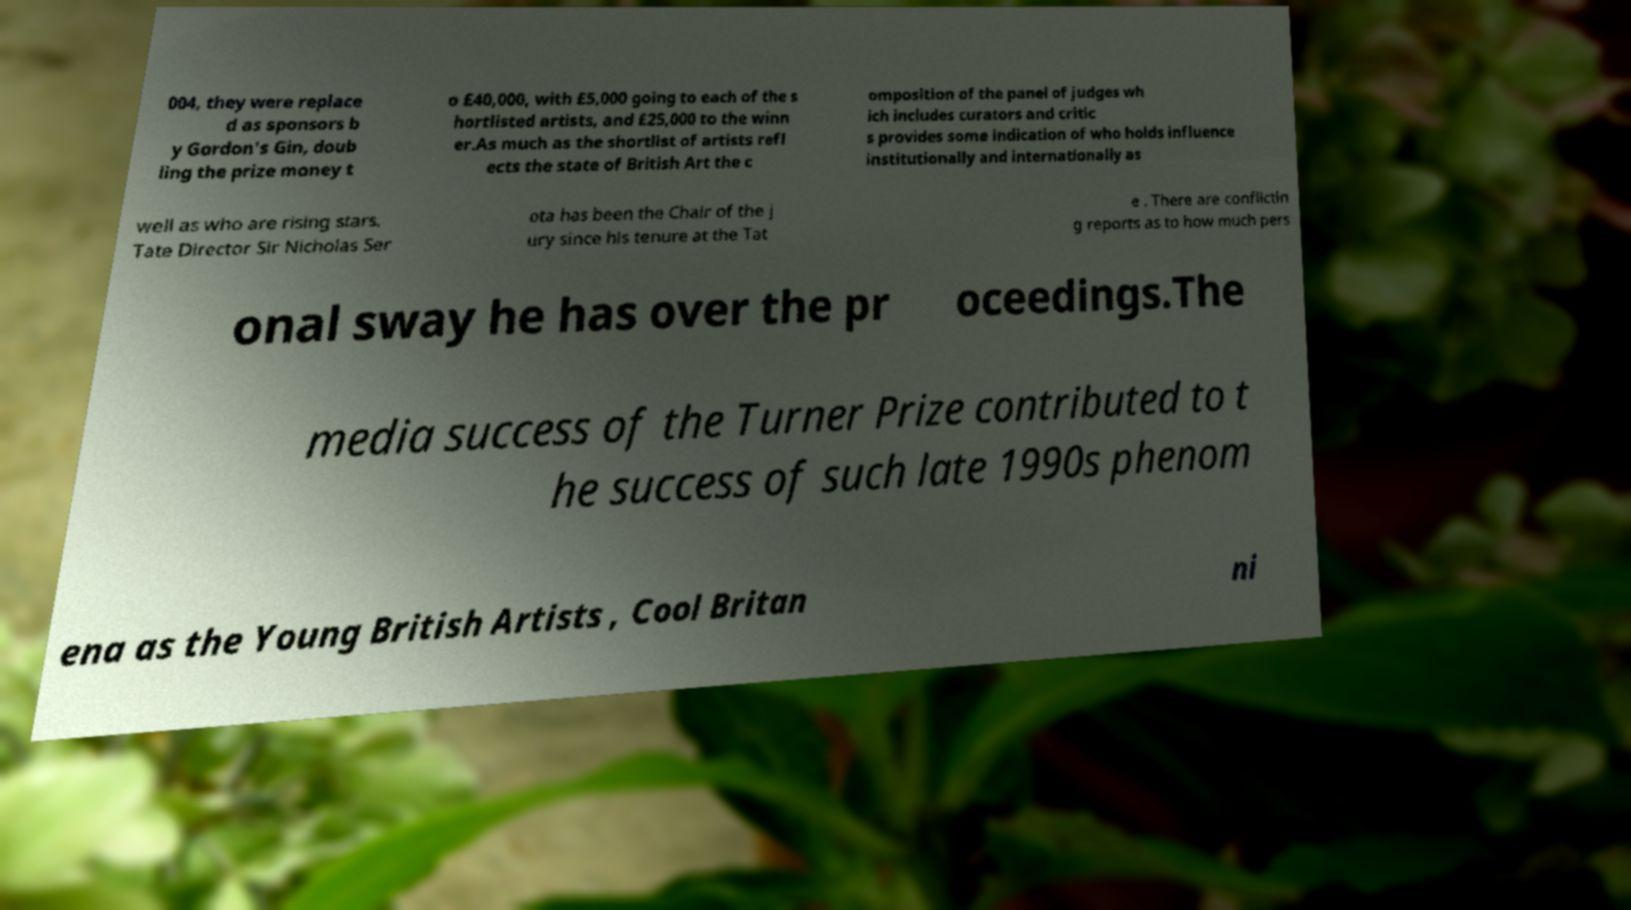For documentation purposes, I need the text within this image transcribed. Could you provide that? 004, they were replace d as sponsors b y Gordon's Gin, doub ling the prize money t o £40,000, with £5,000 going to each of the s hortlisted artists, and £25,000 to the winn er.As much as the shortlist of artists refl ects the state of British Art the c omposition of the panel of judges wh ich includes curators and critic s provides some indication of who holds influence institutionally and internationally as well as who are rising stars. Tate Director Sir Nicholas Ser ota has been the Chair of the j ury since his tenure at the Tat e . There are conflictin g reports as to how much pers onal sway he has over the pr oceedings.The media success of the Turner Prize contributed to t he success of such late 1990s phenom ena as the Young British Artists , Cool Britan ni 